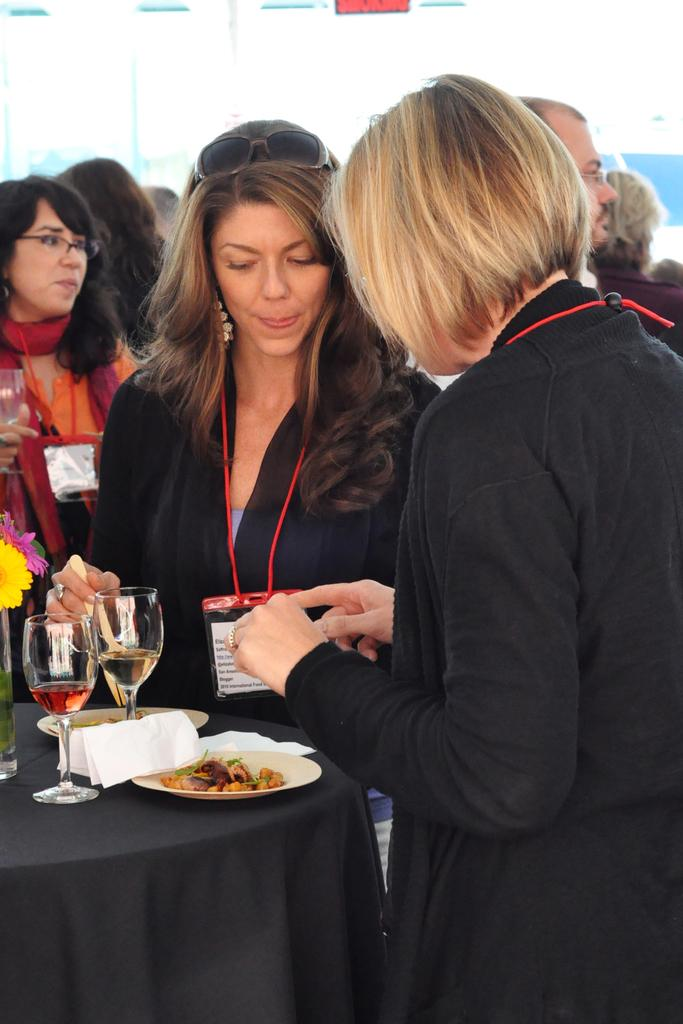What is the main subject of the image? The main subject of the image is a group of people. Can you describe the lady in the image? The lady is standing in the middle of the group. What is in front of the lady? There is a table in front of the lady. What items are on the table? There is a glass, a plate, and a cloth on the table. What statement does the lady make while holding an umbrella in the image? There is no lady holding an umbrella in the image, and no statement is made. 